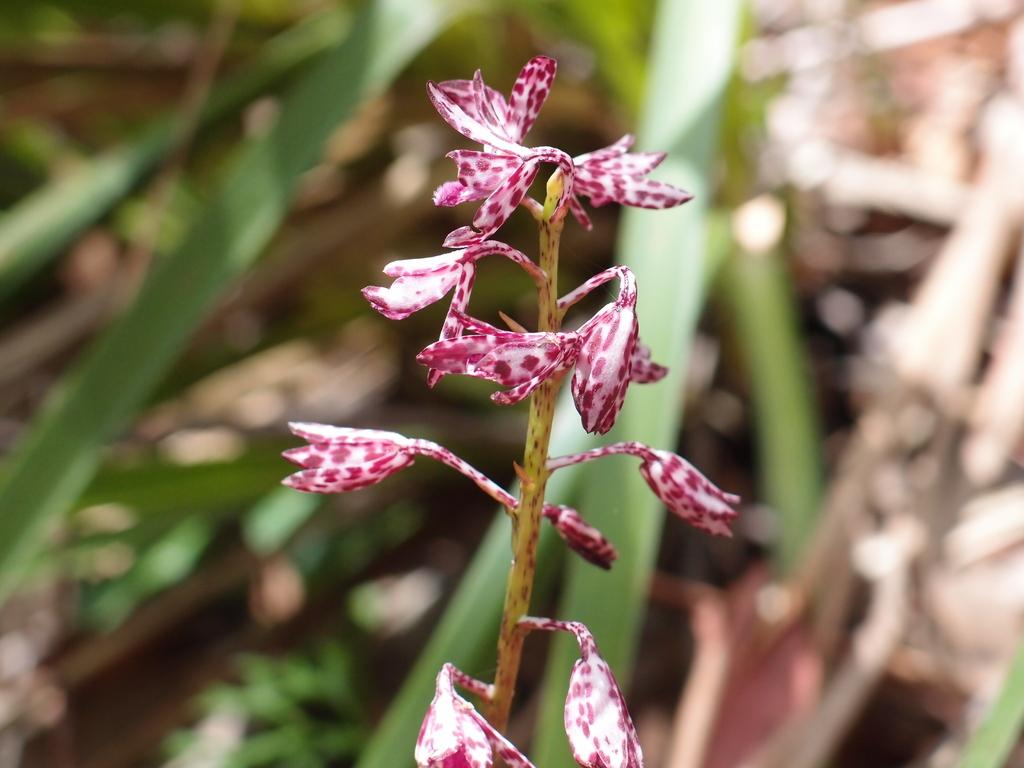What is the main subject of the image? There is a flower in the center of the image. Can you describe the background of the image? The background of the image is blurry. What type of insect is crawling on the sweater in the image? There is no sweater or insect present in the image; it features a flower with a blurry background. 